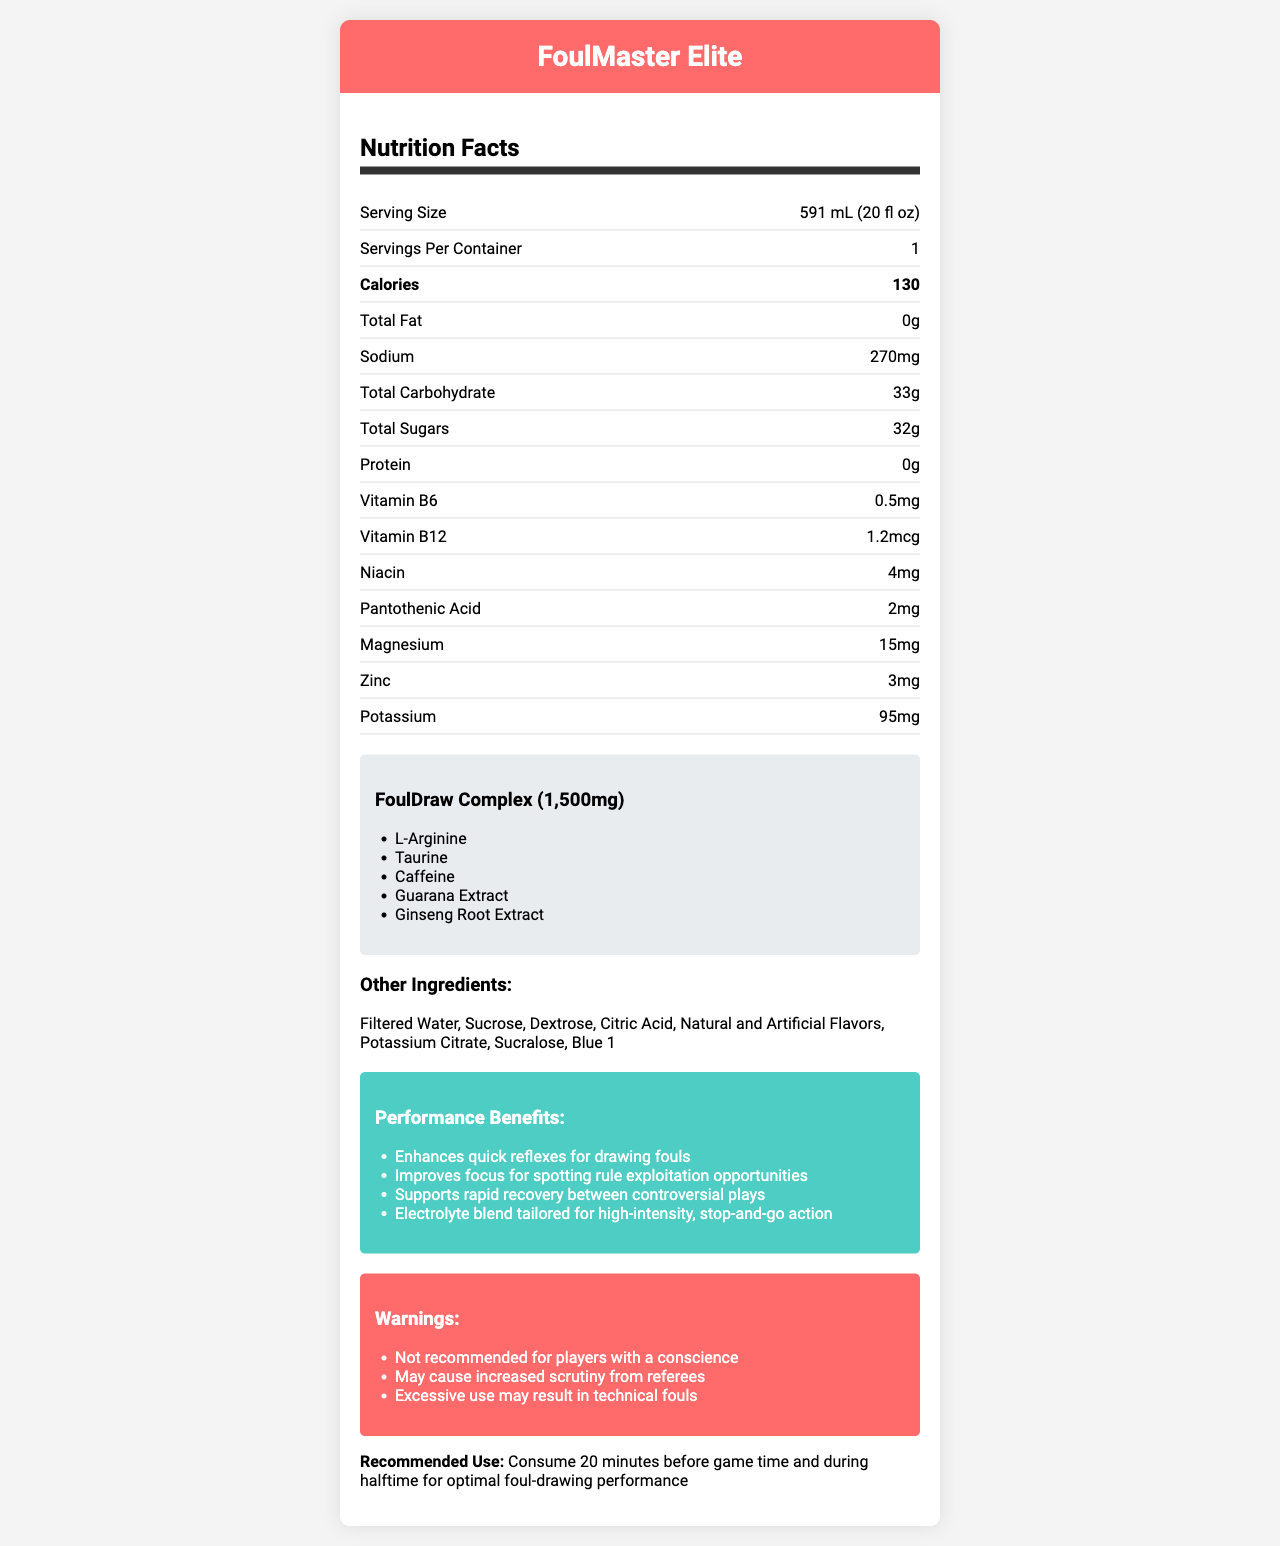what is the serving size for FoulMaster Elite? The serving size is explicitly listed as "591 mL (20 fl oz)" in the document.
Answer: 591 mL (20 fl oz) how many calories are in a serving of FoulMaster Elite? The document lists the caloric content per serving as 130 calories.
Answer: 130 what is the amount of total sugars per serving? The total sugars per serving is given as "32g" in the document.
Answer: 32g how much sodium does each serving contain? The document specifies that there are 270mg of sodium per serving.
Answer: 270mg what is the proprietary blend in FoulMaster Elite called? The proprietary blend is named "FoulDraw Complex" as mentioned in the document.
Answer: FoulDraw Complex how much zinc is in FoulMaster Elite? The document states that there are 3mg of zinc per serving.
Answer: 3mg what are the main marketing claims made for FoulMaster Elite? The document lists these four marketing claims under "Performance Benefits."
Answer: Enhances quick reflexes for drawing fouls, Improves focus for spotting rule exploitation opportunities, Supports rapid recovery between controversial plays, Electrolyte blend tailored for high-intensity, stop-and-go action what should players with a conscience consider before using FoulMaster Elite? One of the warnings in the document states that the product is "Not recommended for players with a conscience."
Answer: Not recommended for players with a conscience which vitamin is present at a quantity of 1.2mcg? A. Vitamin B6 B. Vitamin B12 C. Niacin D. Pantothenic Acid The document specifies that Vitamin B12 is present at a quantity of 1.2mcg.
Answer: B what is the total amount of FoulDraw Complex in a serving? A. 500mg B. 1000mg C. 1500mg D. 2000mg The proprietary blend "FoulDraw Complex" has a total amount of 1,500mg.
Answer: C does FoulMaster Elite contain any protein? The document indicates that the protein content is 0g.
Answer: No are there any potential drawbacks mentioned for excessive use of FoulMaster Elite? The document warns that "Excessive use may result in technical fouls."
Answer: Yes summarize the primary purpose and features of FoulMaster Elite. The document presents FoulMaster Elite as a specialized sports drink to aid athletes in drawing fouls, featuring key nutrients, a proprietary blend, and several marketing claims, alongside specific warnings and recommended use instructions.
Answer: FoulMaster Elite is a sports drink designed to enhance foul-drawing abilities. It includes 130 calories per 591mL serving, with high sugar content (32g). Key nutrients include B vitamins, magnesium, zinc, and potassium. The FoulDraw Complex blend features ingredients like L-Arginine, Taurine, and Caffeine. Marketing claims highlight improved reflexes, focus, and recovery, while warnings caution about ethical concerns and increased referee scrutiny. how much dextrose is used in the FoulMaster Elite formula? The document lists dextrose as an ingredient but does not specify the quantity used.
Answer: Not enough information 